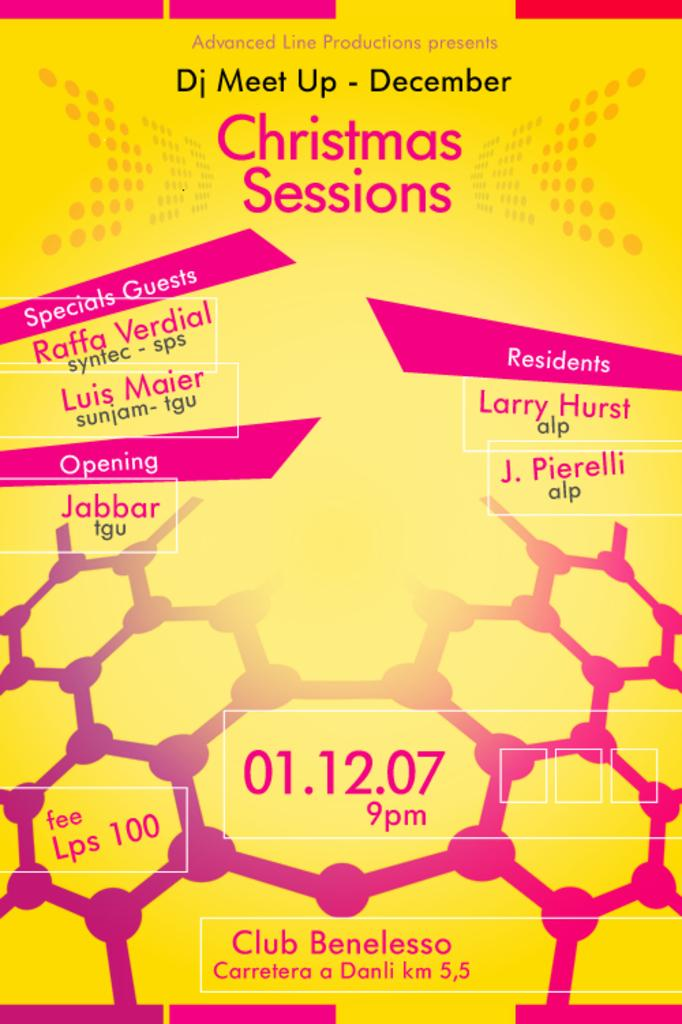<image>
Relay a brief, clear account of the picture shown. A poster advertises the Christmas Sessions, including some special guests. 